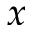Convert formula to latex. <formula><loc_0><loc_0><loc_500><loc_500>x</formula> 